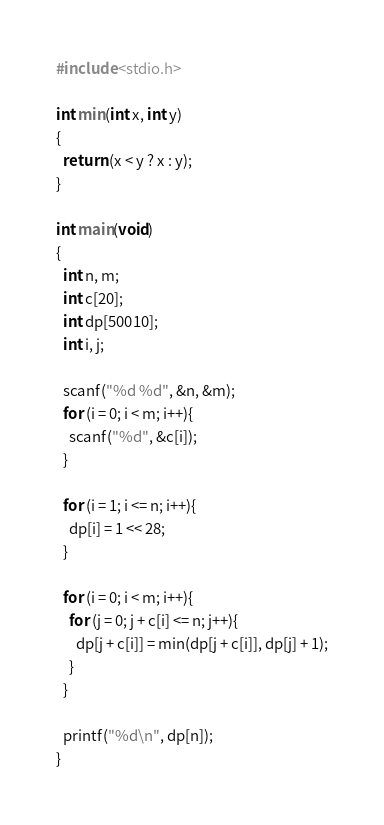<code> <loc_0><loc_0><loc_500><loc_500><_C_>#include <stdio.h>

int min(int x, int y)
{
  return (x < y ? x : y);
}

int main(void)
{
  int n, m;
  int c[20];
  int dp[50010];
  int i, j;

  scanf("%d %d", &n, &m);
  for (i = 0; i < m; i++){
    scanf("%d", &c[i]);
  }

  for (i = 1; i <= n; i++){
    dp[i] = 1 << 28;
  }

  for (i = 0; i < m; i++){
    for (j = 0; j + c[i] <= n; j++){
      dp[j + c[i]] = min(dp[j + c[i]], dp[j] + 1);
    }
  }

  printf("%d\n", dp[n]);
}</code> 